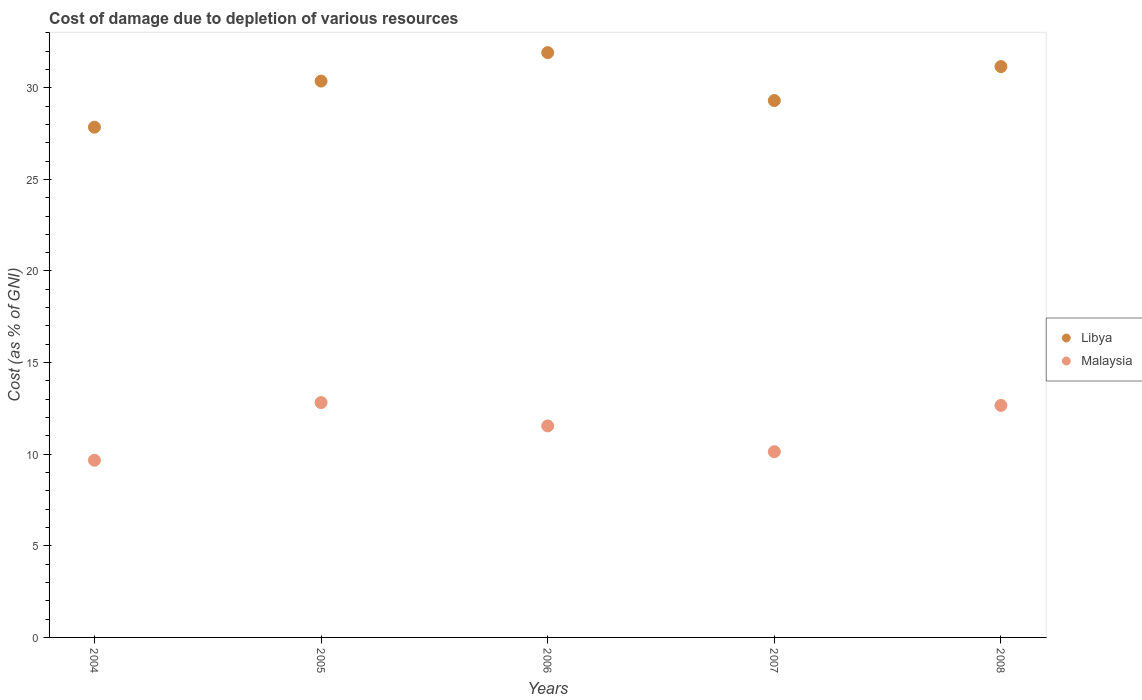How many different coloured dotlines are there?
Offer a very short reply. 2. Is the number of dotlines equal to the number of legend labels?
Provide a succinct answer. Yes. What is the cost of damage caused due to the depletion of various resources in Libya in 2004?
Your answer should be compact. 27.85. Across all years, what is the maximum cost of damage caused due to the depletion of various resources in Malaysia?
Provide a succinct answer. 12.82. Across all years, what is the minimum cost of damage caused due to the depletion of various resources in Libya?
Offer a terse response. 27.85. What is the total cost of damage caused due to the depletion of various resources in Libya in the graph?
Your answer should be compact. 150.59. What is the difference between the cost of damage caused due to the depletion of various resources in Malaysia in 2005 and that in 2008?
Make the answer very short. 0.15. What is the difference between the cost of damage caused due to the depletion of various resources in Malaysia in 2006 and the cost of damage caused due to the depletion of various resources in Libya in 2005?
Your answer should be very brief. -18.82. What is the average cost of damage caused due to the depletion of various resources in Libya per year?
Your response must be concise. 30.12. In the year 2005, what is the difference between the cost of damage caused due to the depletion of various resources in Malaysia and cost of damage caused due to the depletion of various resources in Libya?
Provide a short and direct response. -17.55. In how many years, is the cost of damage caused due to the depletion of various resources in Malaysia greater than 16 %?
Your response must be concise. 0. What is the ratio of the cost of damage caused due to the depletion of various resources in Libya in 2004 to that in 2006?
Your response must be concise. 0.87. Is the difference between the cost of damage caused due to the depletion of various resources in Malaysia in 2007 and 2008 greater than the difference between the cost of damage caused due to the depletion of various resources in Libya in 2007 and 2008?
Your answer should be compact. No. What is the difference between the highest and the second highest cost of damage caused due to the depletion of various resources in Libya?
Provide a succinct answer. 0.76. What is the difference between the highest and the lowest cost of damage caused due to the depletion of various resources in Malaysia?
Offer a very short reply. 3.15. Is the cost of damage caused due to the depletion of various resources in Malaysia strictly greater than the cost of damage caused due to the depletion of various resources in Libya over the years?
Offer a very short reply. No. Is the cost of damage caused due to the depletion of various resources in Libya strictly less than the cost of damage caused due to the depletion of various resources in Malaysia over the years?
Keep it short and to the point. No. Are the values on the major ticks of Y-axis written in scientific E-notation?
Make the answer very short. No. Does the graph contain any zero values?
Ensure brevity in your answer.  No. How many legend labels are there?
Your answer should be very brief. 2. What is the title of the graph?
Make the answer very short. Cost of damage due to depletion of various resources. Does "Iran" appear as one of the legend labels in the graph?
Make the answer very short. No. What is the label or title of the X-axis?
Give a very brief answer. Years. What is the label or title of the Y-axis?
Provide a succinct answer. Cost (as % of GNI). What is the Cost (as % of GNI) of Libya in 2004?
Provide a succinct answer. 27.85. What is the Cost (as % of GNI) of Malaysia in 2004?
Give a very brief answer. 9.67. What is the Cost (as % of GNI) in Libya in 2005?
Give a very brief answer. 30.36. What is the Cost (as % of GNI) in Malaysia in 2005?
Offer a terse response. 12.82. What is the Cost (as % of GNI) in Libya in 2006?
Give a very brief answer. 31.92. What is the Cost (as % of GNI) in Malaysia in 2006?
Make the answer very short. 11.54. What is the Cost (as % of GNI) in Libya in 2007?
Provide a short and direct response. 29.3. What is the Cost (as % of GNI) in Malaysia in 2007?
Your response must be concise. 10.14. What is the Cost (as % of GNI) in Libya in 2008?
Ensure brevity in your answer.  31.16. What is the Cost (as % of GNI) in Malaysia in 2008?
Give a very brief answer. 12.66. Across all years, what is the maximum Cost (as % of GNI) in Libya?
Offer a very short reply. 31.92. Across all years, what is the maximum Cost (as % of GNI) in Malaysia?
Ensure brevity in your answer.  12.82. Across all years, what is the minimum Cost (as % of GNI) of Libya?
Your answer should be very brief. 27.85. Across all years, what is the minimum Cost (as % of GNI) in Malaysia?
Provide a succinct answer. 9.67. What is the total Cost (as % of GNI) of Libya in the graph?
Make the answer very short. 150.59. What is the total Cost (as % of GNI) in Malaysia in the graph?
Your response must be concise. 56.83. What is the difference between the Cost (as % of GNI) in Libya in 2004 and that in 2005?
Offer a very short reply. -2.52. What is the difference between the Cost (as % of GNI) of Malaysia in 2004 and that in 2005?
Keep it short and to the point. -3.15. What is the difference between the Cost (as % of GNI) of Libya in 2004 and that in 2006?
Your response must be concise. -4.07. What is the difference between the Cost (as % of GNI) of Malaysia in 2004 and that in 2006?
Offer a terse response. -1.87. What is the difference between the Cost (as % of GNI) of Libya in 2004 and that in 2007?
Offer a terse response. -1.45. What is the difference between the Cost (as % of GNI) in Malaysia in 2004 and that in 2007?
Your answer should be compact. -0.47. What is the difference between the Cost (as % of GNI) in Libya in 2004 and that in 2008?
Offer a terse response. -3.31. What is the difference between the Cost (as % of GNI) in Malaysia in 2004 and that in 2008?
Your answer should be compact. -2.99. What is the difference between the Cost (as % of GNI) of Libya in 2005 and that in 2006?
Provide a short and direct response. -1.55. What is the difference between the Cost (as % of GNI) of Malaysia in 2005 and that in 2006?
Offer a terse response. 1.27. What is the difference between the Cost (as % of GNI) of Libya in 2005 and that in 2007?
Ensure brevity in your answer.  1.06. What is the difference between the Cost (as % of GNI) in Malaysia in 2005 and that in 2007?
Make the answer very short. 2.68. What is the difference between the Cost (as % of GNI) in Libya in 2005 and that in 2008?
Your answer should be compact. -0.79. What is the difference between the Cost (as % of GNI) in Malaysia in 2005 and that in 2008?
Keep it short and to the point. 0.15. What is the difference between the Cost (as % of GNI) in Libya in 2006 and that in 2007?
Ensure brevity in your answer.  2.62. What is the difference between the Cost (as % of GNI) in Malaysia in 2006 and that in 2007?
Make the answer very short. 1.41. What is the difference between the Cost (as % of GNI) of Libya in 2006 and that in 2008?
Keep it short and to the point. 0.76. What is the difference between the Cost (as % of GNI) in Malaysia in 2006 and that in 2008?
Your response must be concise. -1.12. What is the difference between the Cost (as % of GNI) in Libya in 2007 and that in 2008?
Provide a succinct answer. -1.85. What is the difference between the Cost (as % of GNI) in Malaysia in 2007 and that in 2008?
Offer a very short reply. -2.53. What is the difference between the Cost (as % of GNI) of Libya in 2004 and the Cost (as % of GNI) of Malaysia in 2005?
Ensure brevity in your answer.  15.03. What is the difference between the Cost (as % of GNI) of Libya in 2004 and the Cost (as % of GNI) of Malaysia in 2006?
Provide a short and direct response. 16.3. What is the difference between the Cost (as % of GNI) of Libya in 2004 and the Cost (as % of GNI) of Malaysia in 2007?
Offer a very short reply. 17.71. What is the difference between the Cost (as % of GNI) in Libya in 2004 and the Cost (as % of GNI) in Malaysia in 2008?
Make the answer very short. 15.18. What is the difference between the Cost (as % of GNI) of Libya in 2005 and the Cost (as % of GNI) of Malaysia in 2006?
Give a very brief answer. 18.82. What is the difference between the Cost (as % of GNI) in Libya in 2005 and the Cost (as % of GNI) in Malaysia in 2007?
Offer a terse response. 20.23. What is the difference between the Cost (as % of GNI) of Libya in 2005 and the Cost (as % of GNI) of Malaysia in 2008?
Give a very brief answer. 17.7. What is the difference between the Cost (as % of GNI) in Libya in 2006 and the Cost (as % of GNI) in Malaysia in 2007?
Your answer should be very brief. 21.78. What is the difference between the Cost (as % of GNI) of Libya in 2006 and the Cost (as % of GNI) of Malaysia in 2008?
Your response must be concise. 19.25. What is the difference between the Cost (as % of GNI) of Libya in 2007 and the Cost (as % of GNI) of Malaysia in 2008?
Provide a succinct answer. 16.64. What is the average Cost (as % of GNI) in Libya per year?
Ensure brevity in your answer.  30.12. What is the average Cost (as % of GNI) in Malaysia per year?
Give a very brief answer. 11.37. In the year 2004, what is the difference between the Cost (as % of GNI) in Libya and Cost (as % of GNI) in Malaysia?
Make the answer very short. 18.18. In the year 2005, what is the difference between the Cost (as % of GNI) in Libya and Cost (as % of GNI) in Malaysia?
Your response must be concise. 17.55. In the year 2006, what is the difference between the Cost (as % of GNI) of Libya and Cost (as % of GNI) of Malaysia?
Make the answer very short. 20.37. In the year 2007, what is the difference between the Cost (as % of GNI) in Libya and Cost (as % of GNI) in Malaysia?
Ensure brevity in your answer.  19.17. In the year 2008, what is the difference between the Cost (as % of GNI) in Libya and Cost (as % of GNI) in Malaysia?
Your answer should be very brief. 18.49. What is the ratio of the Cost (as % of GNI) in Libya in 2004 to that in 2005?
Provide a short and direct response. 0.92. What is the ratio of the Cost (as % of GNI) of Malaysia in 2004 to that in 2005?
Your response must be concise. 0.75. What is the ratio of the Cost (as % of GNI) in Libya in 2004 to that in 2006?
Give a very brief answer. 0.87. What is the ratio of the Cost (as % of GNI) of Malaysia in 2004 to that in 2006?
Make the answer very short. 0.84. What is the ratio of the Cost (as % of GNI) in Libya in 2004 to that in 2007?
Offer a terse response. 0.95. What is the ratio of the Cost (as % of GNI) of Malaysia in 2004 to that in 2007?
Provide a succinct answer. 0.95. What is the ratio of the Cost (as % of GNI) of Libya in 2004 to that in 2008?
Your answer should be compact. 0.89. What is the ratio of the Cost (as % of GNI) in Malaysia in 2004 to that in 2008?
Your answer should be compact. 0.76. What is the ratio of the Cost (as % of GNI) of Libya in 2005 to that in 2006?
Your response must be concise. 0.95. What is the ratio of the Cost (as % of GNI) in Malaysia in 2005 to that in 2006?
Provide a succinct answer. 1.11. What is the ratio of the Cost (as % of GNI) in Libya in 2005 to that in 2007?
Ensure brevity in your answer.  1.04. What is the ratio of the Cost (as % of GNI) in Malaysia in 2005 to that in 2007?
Make the answer very short. 1.26. What is the ratio of the Cost (as % of GNI) of Libya in 2005 to that in 2008?
Provide a succinct answer. 0.97. What is the ratio of the Cost (as % of GNI) in Malaysia in 2005 to that in 2008?
Offer a very short reply. 1.01. What is the ratio of the Cost (as % of GNI) of Libya in 2006 to that in 2007?
Your answer should be very brief. 1.09. What is the ratio of the Cost (as % of GNI) in Malaysia in 2006 to that in 2007?
Keep it short and to the point. 1.14. What is the ratio of the Cost (as % of GNI) in Libya in 2006 to that in 2008?
Keep it short and to the point. 1.02. What is the ratio of the Cost (as % of GNI) of Malaysia in 2006 to that in 2008?
Ensure brevity in your answer.  0.91. What is the ratio of the Cost (as % of GNI) of Libya in 2007 to that in 2008?
Keep it short and to the point. 0.94. What is the ratio of the Cost (as % of GNI) in Malaysia in 2007 to that in 2008?
Provide a succinct answer. 0.8. What is the difference between the highest and the second highest Cost (as % of GNI) of Libya?
Provide a short and direct response. 0.76. What is the difference between the highest and the second highest Cost (as % of GNI) of Malaysia?
Your answer should be very brief. 0.15. What is the difference between the highest and the lowest Cost (as % of GNI) of Libya?
Ensure brevity in your answer.  4.07. What is the difference between the highest and the lowest Cost (as % of GNI) of Malaysia?
Offer a terse response. 3.15. 